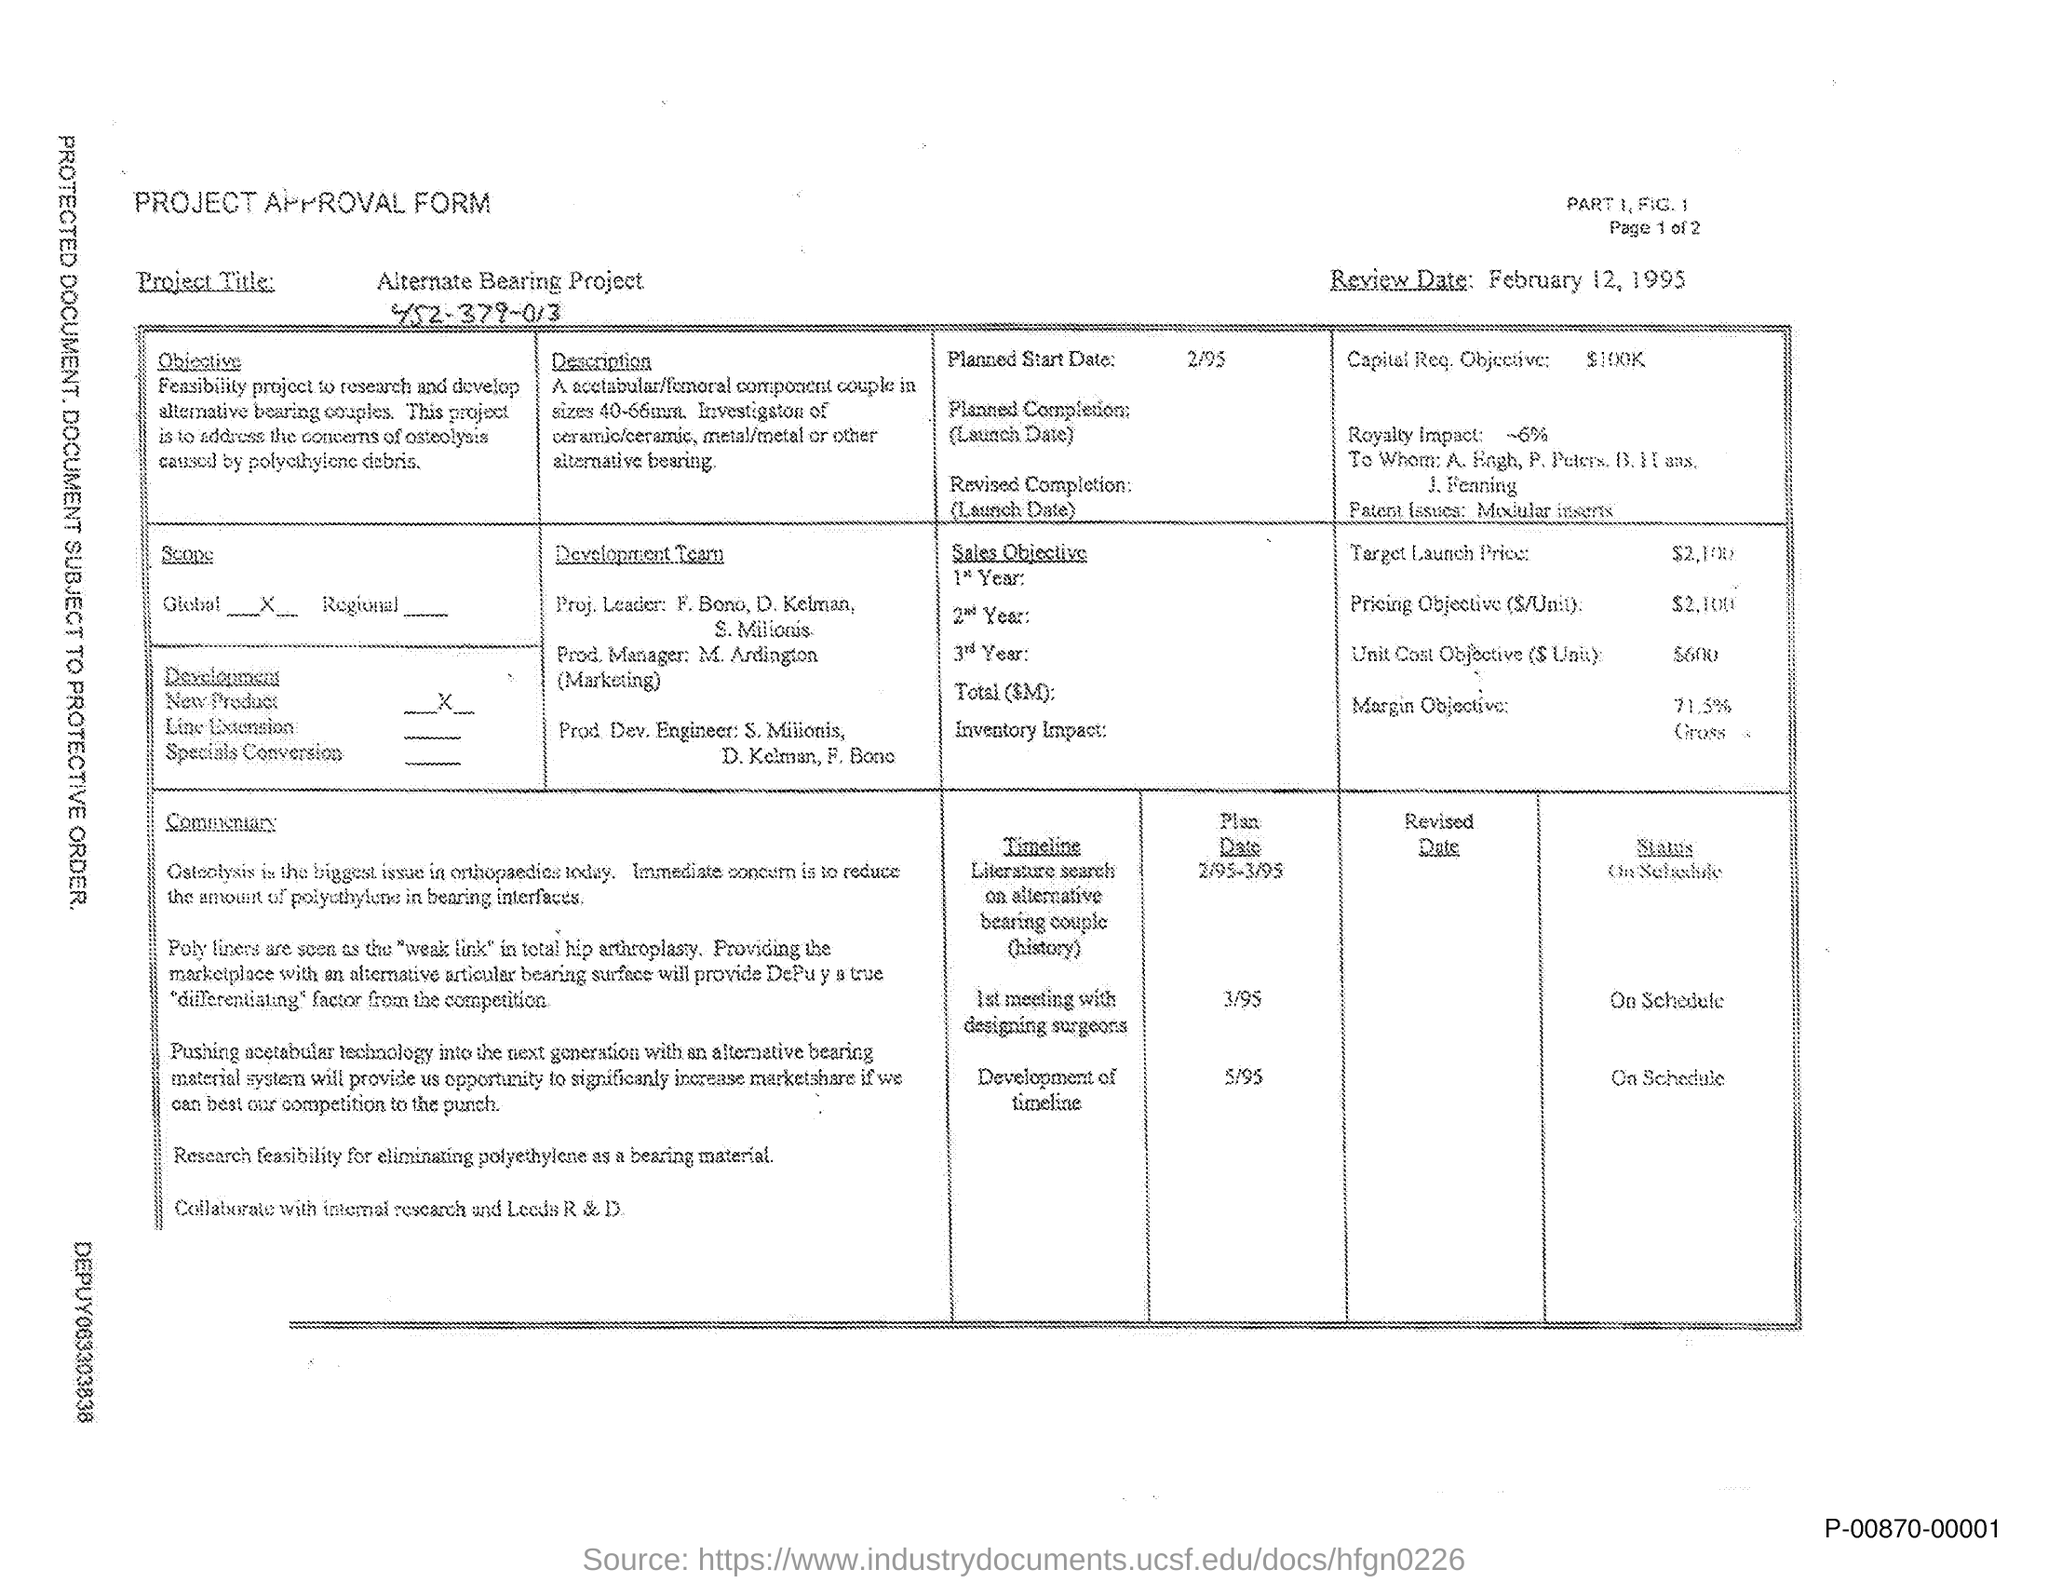What type of form is given here?
Your answer should be compact. Project approval form. What is the Project title given in the form?
Ensure brevity in your answer.  Alternate Bearing Project. How much is the Capital Req. Objective given in the form?
Your answer should be very brief. $100K. What is the planned start date of the project?
Give a very brief answer. 2/95. Who are the Proj. Leaders for the Development team?
Provide a short and direct response. F. Bono, D. Kelman, S. Milionis. What is the scope of the project?
Your response must be concise. Global. 